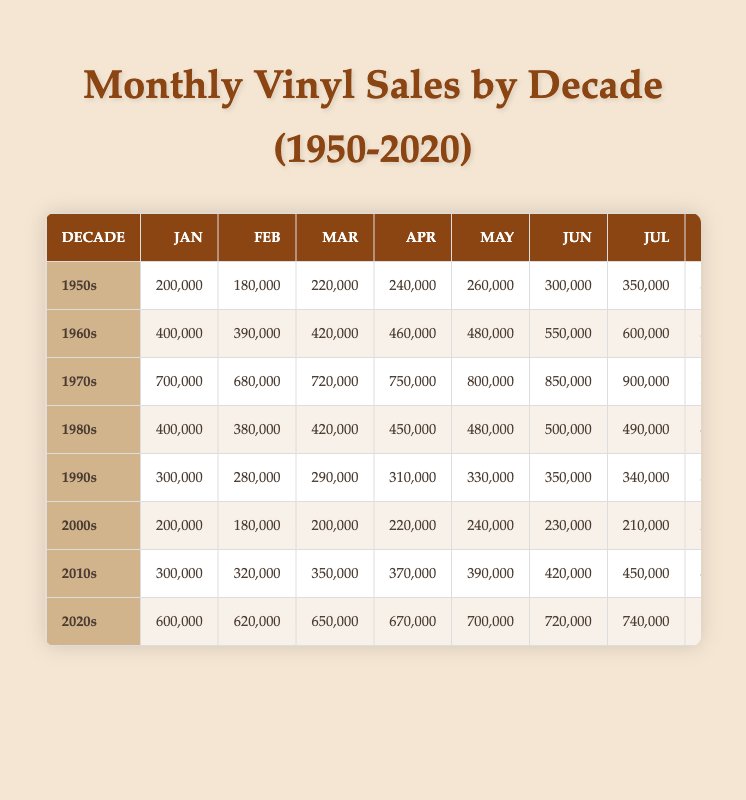What were the monthly sales in December 1970? The table indicates that the sales in December 1970 are recorded under the 1970s decade. The value provided for December is 1,000,000.
Answer: 1,000,000 Which decade had the highest average monthly sales? To find the average sales for each decade, I calculate the total sales for each decade and divide by 12 (the number of months). The 1970s average is (7,000,000 total sales / 12) = 833,333. The 1960s average is (5,900,000 / 12) = 491,667, the 1980s average is (5,360,000 / 12) = 446,667, the 1990s average is (3,460,000 / 12) = 288,333, the 2000s average is (2,620,000 / 12) = 218,333, the 2010s average is (5,080,000 / 12) = 423,333, and the 2020s average is (8,370,000 / 12) = 697,500. Hence, the highest average is for the 1970s.
Answer: 1970s Did vinyl sales in the 2000s exceed those in the 2010s in any month? I review the monthly sales figures for both decades. In the 2010s, the sales in every month are higher than the corresponding month in the 2000s. For instance, January 2010 had 200,000 sales, while January 2011 had 300,000. Thus, the assertion is false.
Answer: No What was the total monthly sales for the 1960s? To find the total sales for the 1960s, I sum the monthly figures: 400,000 + 390,000 + ... + 700,000 = 7,140,000. Thus, this represents the overall sales for that decade.
Answer: 7,140,000 Which month had the lowest sales in the 1980s? Looking through the monthly sales for the 1980s, the lowest figure is in February with 380,000. That is the smallest number when compared to other months in the same decade.
Answer: February How did the total sales in the 1990s compare to the total sales in the 2020s? Summing total sales for the 1990s gives 3,460,000; for the 2020s, it is 8,370,000. Thus, 8,370,000 is greater than 3,460,000, indicating that sales increased significantly in the 2020s compared to the 1990s.
Answer: Increased What was the growth rate of vinyl record sales from the 1950s to the 1970s? First, I determine the sales for January in both decades: 1950s had 200,000 and 1970s had 700,000. Growth is calculated as ((700,000 - 200,000) / 200,000) * 100 = 250%. This indicates a significant increase in sales over those two decades.
Answer: 250% In which month of the 2010s did sales peak? Checking the 2010s, December shows the highest sales figure of 500,000 compared to all other months in that decade, indicating it was the peak month for sales.
Answer: December What were the sales figures for July in the 2020s compared to those in the 1960s? July 2020s shows 740,000 while the 1960s shows 600,000. The 2020s figure exceeds the 1960s figure by 140,000. This highlights a notable increase in sales in July within that timeframe.
Answer: 740,000 vs 600,000 (2020 > 1960) 